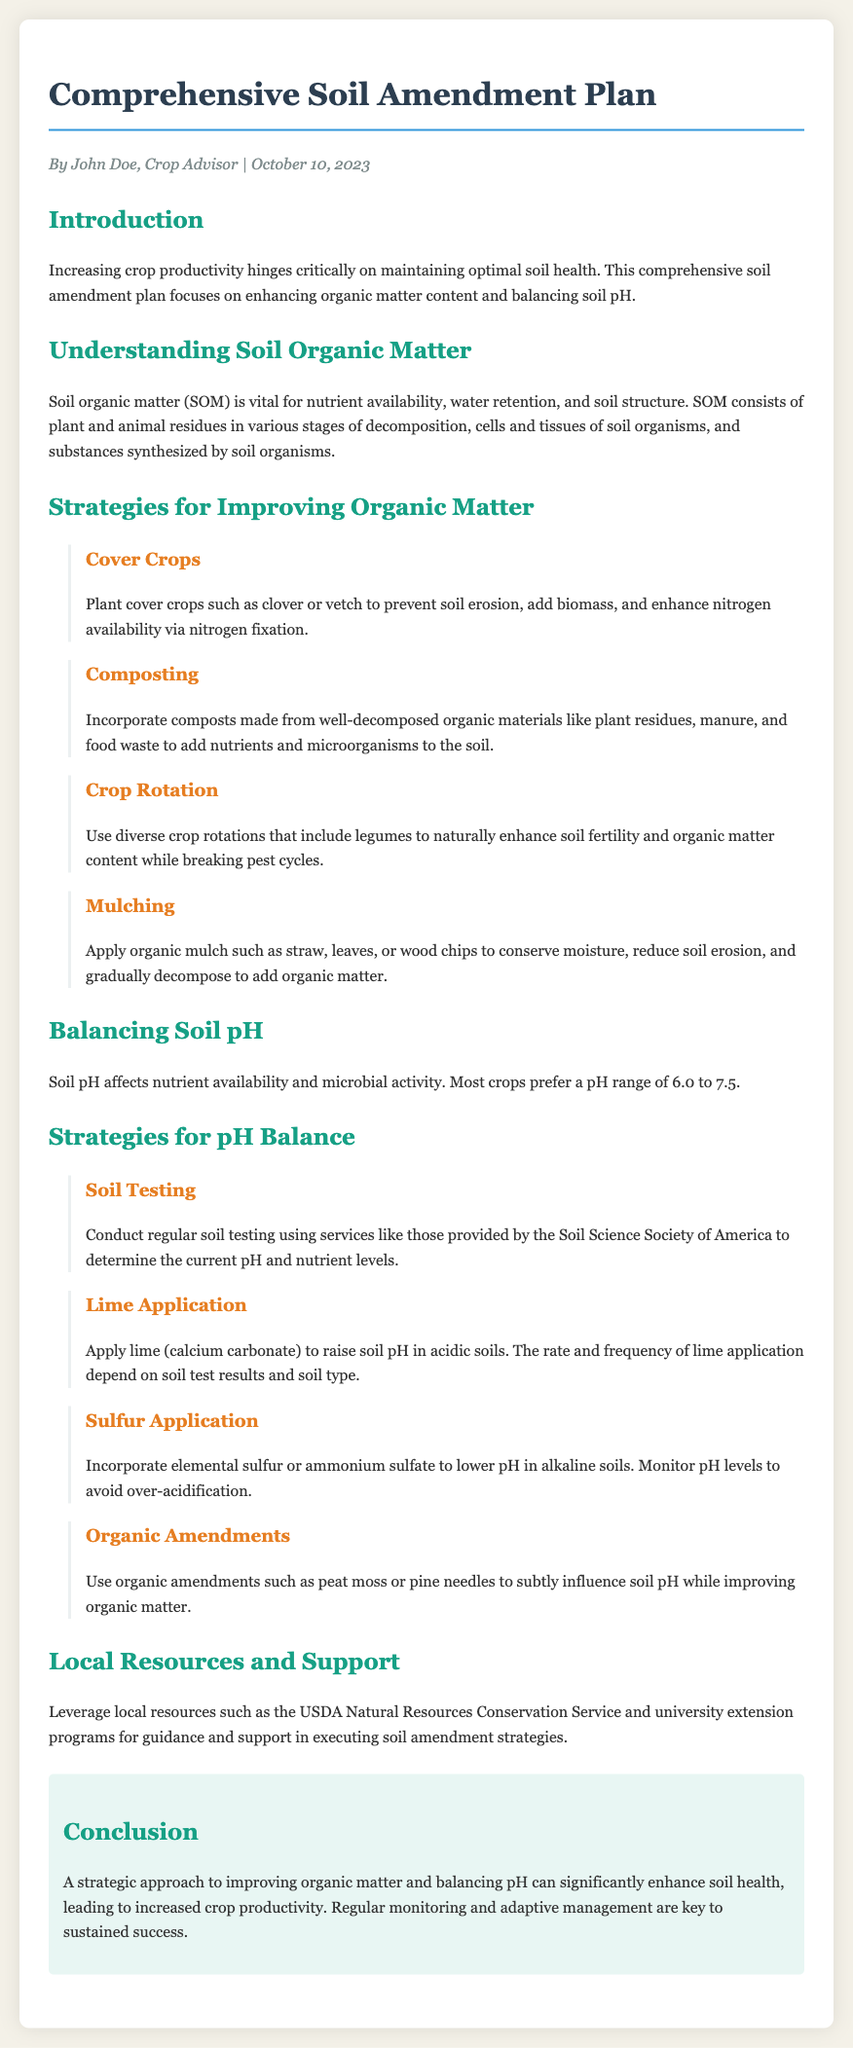What is the primary focus of the soil amendment plan? The primary focus is on enhancing organic matter content and balancing soil pH.
Answer: enhancing organic matter content and balancing soil pH Who is the author of the document? The document is authored by John Doe, Crop Advisor.
Answer: John Doe What date was the document published? The document was published on October 10, 2023.
Answer: October 10, 2023 What is one strategy mentioned for improving organic matter? Cover crops, composting, crop rotation, or mulching are strategies mentioned.
Answer: Cover crops What is the preferred pH range for most crops? The preferred pH range for most crops is 6.0 to 7.5.
Answer: 6.0 to 7.5 Which local resource is suggested for guidance? The USDA Natural Resources Conservation Service is suggested for guidance.
Answer: USDA Natural Resources Conservation Service What is one method for raising soil pH? Applying lime (calcium carbonate) is one method for raising soil pH.
Answer: lime (calcium carbonate) What should be done before applying sulfur to lower pH? Monitor pH levels to avoid over-acidification should be done before applying sulfur.
Answer: Monitor pH levels What is the conclusion of the document regarding soil health? A strategic approach to improving organic matter and balancing pH can significantly enhance soil health.
Answer: significantly enhance soil health 